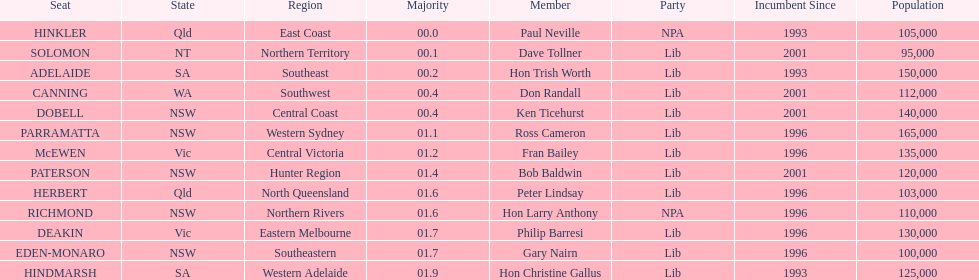What is the total of seats? 13. Parse the full table. {'header': ['Seat', 'State', 'Region', 'Majority', 'Member', 'Party', 'Incumbent Since', 'Population'], 'rows': [['HINKLER', 'Qld', 'East Coast', '00.0', 'Paul Neville', 'NPA', '1993', '105,000'], ['SOLOMON', 'NT', 'Northern Territory', '00.1', 'Dave Tollner', 'Lib', '2001', '95,000'], ['ADELAIDE', 'SA', 'Southeast', '00.2', 'Hon Trish Worth', 'Lib', '1993', '150,000'], ['CANNING', 'WA', 'Southwest', '00.4', 'Don Randall', 'Lib', '2001', '112,000'], ['DOBELL', 'NSW', 'Central Coast', '00.4', 'Ken Ticehurst', 'Lib', '2001', '140,000'], ['PARRAMATTA', 'NSW', 'Western Sydney', '01.1', 'Ross Cameron', 'Lib', '1996', '165,000'], ['McEWEN', 'Vic', 'Central Victoria', '01.2', 'Fran Bailey', 'Lib', '1996', '135,000'], ['PATERSON', 'NSW', 'Hunter Region', '01.4', 'Bob Baldwin', 'Lib', '2001', '120,000'], ['HERBERT', 'Qld', 'North Queensland', '01.6', 'Peter Lindsay', 'Lib', '1996', '103,000'], ['RICHMOND', 'NSW', 'Northern Rivers', '01.6', 'Hon Larry Anthony', 'NPA', '1996', '110,000'], ['DEAKIN', 'Vic', 'Eastern Melbourne', '01.7', 'Philip Barresi', 'Lib', '1996', '130,000'], ['EDEN-MONARO', 'NSW', 'Southeastern', '01.7', 'Gary Nairn', 'Lib', '1996', '100,000'], ['HINDMARSH', 'SA', 'Western Adelaide', '01.9', 'Hon Christine Gallus', 'Lib', '1993', '125,000']]} 